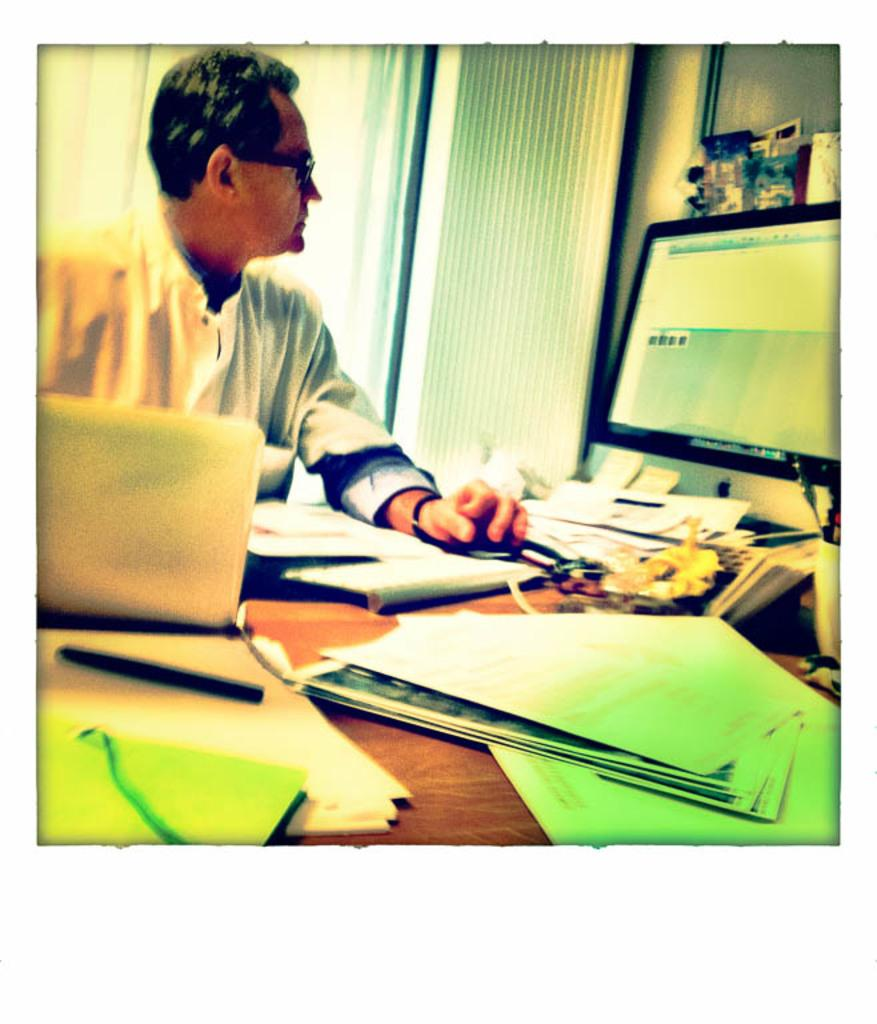Who is the main subject in the image? There is a man in the image. What is the man doing in the image? The man is sitting in the image. Where is the man located in relation to the table? The man is in front of a table in the image. What objects are on the table? There is a computer and papers on the table in the image. What accessory is the man wearing? The man is wearing spectacles in the image. What things does the man remember about his childhood in the image? There is no information about the man's memories in the image. Who is the owner of the computer in the image? There is no information about the ownership of the computer in the image. 